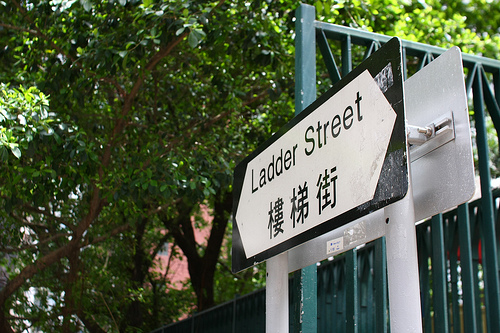<image>
Is the railing behind the street sign? Yes. From this viewpoint, the railing is positioned behind the street sign, with the street sign partially or fully occluding the railing. Is there a street sign behind the tree? No. The street sign is not behind the tree. From this viewpoint, the street sign appears to be positioned elsewhere in the scene. 